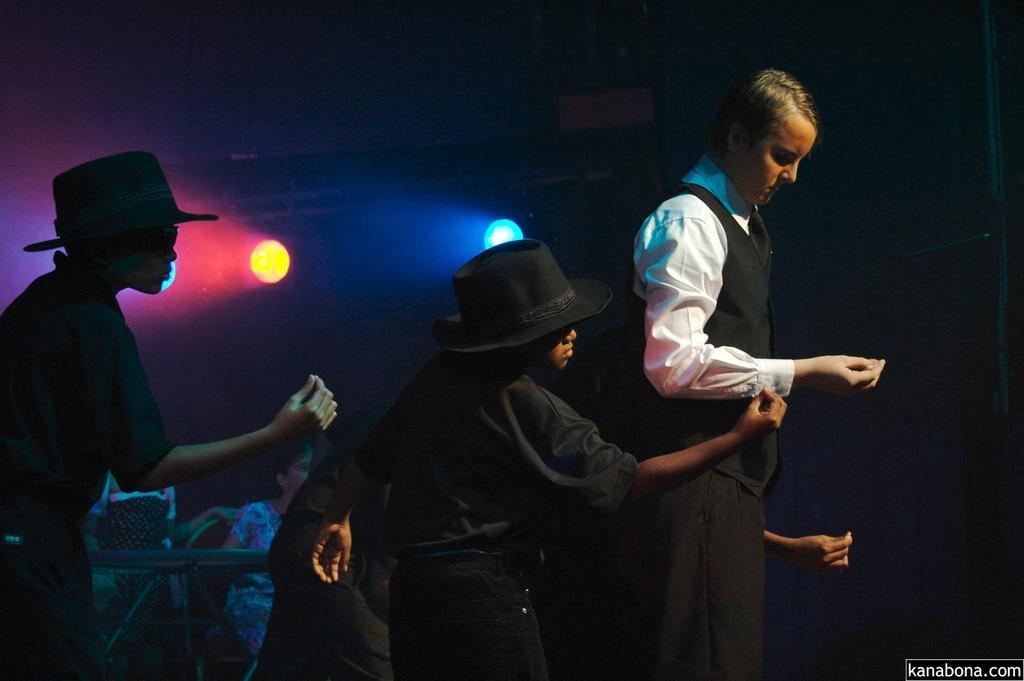Could you give a brief overview of what you see in this image? In this image there are three people standing and two of them are wearing hats, and it seems that they are dancing. And in the background there are some people, lights and some objects. And there is a dark background. 